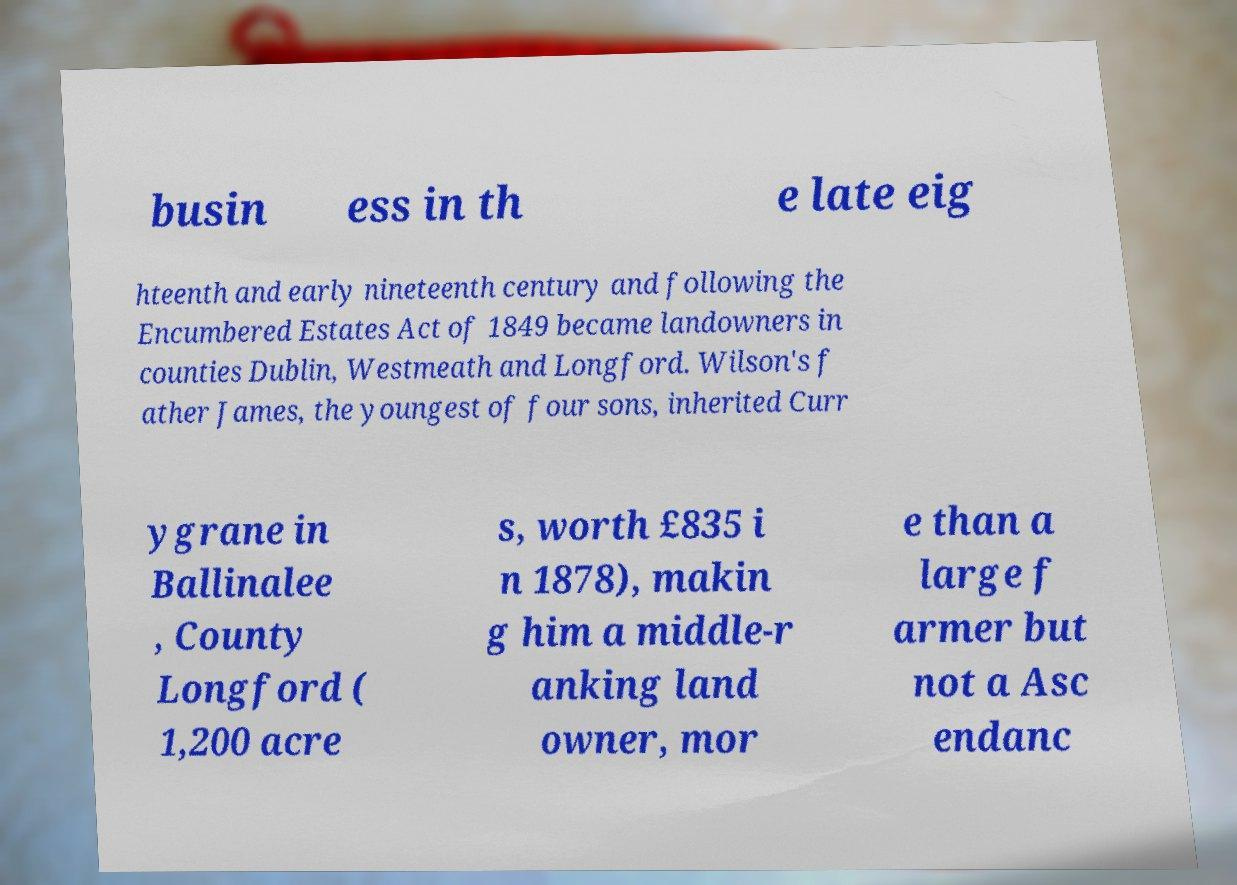I need the written content from this picture converted into text. Can you do that? busin ess in th e late eig hteenth and early nineteenth century and following the Encumbered Estates Act of 1849 became landowners in counties Dublin, Westmeath and Longford. Wilson's f ather James, the youngest of four sons, inherited Curr ygrane in Ballinalee , County Longford ( 1,200 acre s, worth £835 i n 1878), makin g him a middle-r anking land owner, mor e than a large f armer but not a Asc endanc 